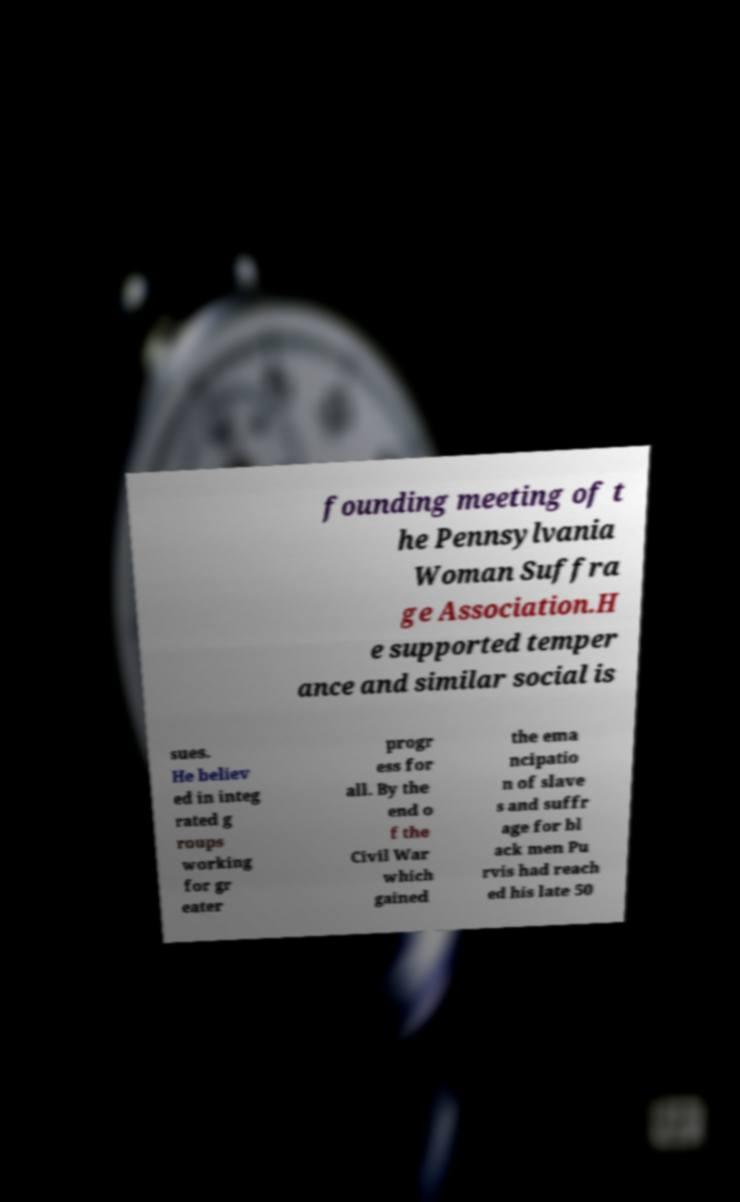Can you read and provide the text displayed in the image?This photo seems to have some interesting text. Can you extract and type it out for me? founding meeting of t he Pennsylvania Woman Suffra ge Association.H e supported temper ance and similar social is sues. He believ ed in integ rated g roups working for gr eater progr ess for all. By the end o f the Civil War which gained the ema ncipatio n of slave s and suffr age for bl ack men Pu rvis had reach ed his late 50 